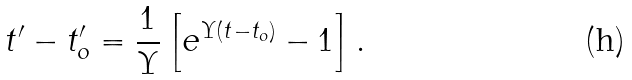<formula> <loc_0><loc_0><loc_500><loc_500>t ^ { \prime } - t _ { o } ^ { \prime } = \frac { 1 } { \Upsilon } \left [ e ^ { \Upsilon ( t - t _ { o } ) } - 1 \right ] .</formula> 